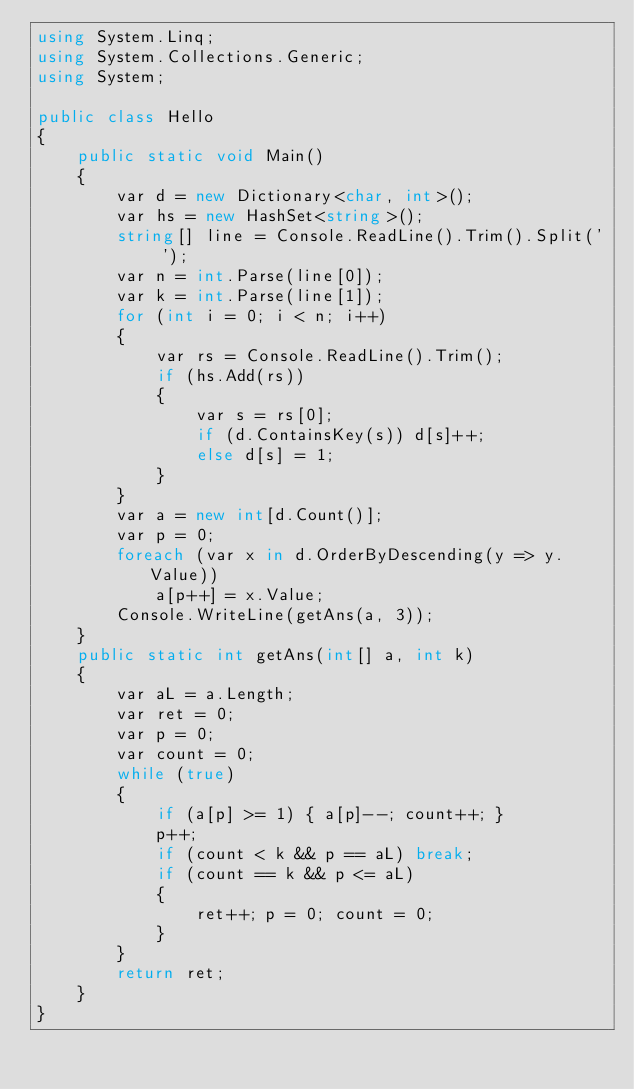Convert code to text. <code><loc_0><loc_0><loc_500><loc_500><_C#_>using System.Linq;
using System.Collections.Generic;
using System;

public class Hello
{
    public static void Main()
    {
        var d = new Dictionary<char, int>();
        var hs = new HashSet<string>();
        string[] line = Console.ReadLine().Trim().Split(' ');
        var n = int.Parse(line[0]);
        var k = int.Parse(line[1]);
        for (int i = 0; i < n; i++)
        {
            var rs = Console.ReadLine().Trim();
            if (hs.Add(rs))
            {
                var s = rs[0];
                if (d.ContainsKey(s)) d[s]++;
                else d[s] = 1;
            }
        }
        var a = new int[d.Count()];
        var p = 0;
        foreach (var x in d.OrderByDescending(y => y.Value))
            a[p++] = x.Value;
        Console.WriteLine(getAns(a, 3));
    }
    public static int getAns(int[] a, int k)
    {
        var aL = a.Length;
        var ret = 0;
        var p = 0;
        var count = 0;
        while (true)
        {
            if (a[p] >= 1) { a[p]--; count++; }
            p++;
            if (count < k && p == aL) break;
            if (count == k && p <= aL)
            {
                ret++; p = 0; count = 0;
            }
        }
        return ret;
    }
}
</code> 